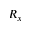Convert formula to latex. <formula><loc_0><loc_0><loc_500><loc_500>R _ { x }</formula> 